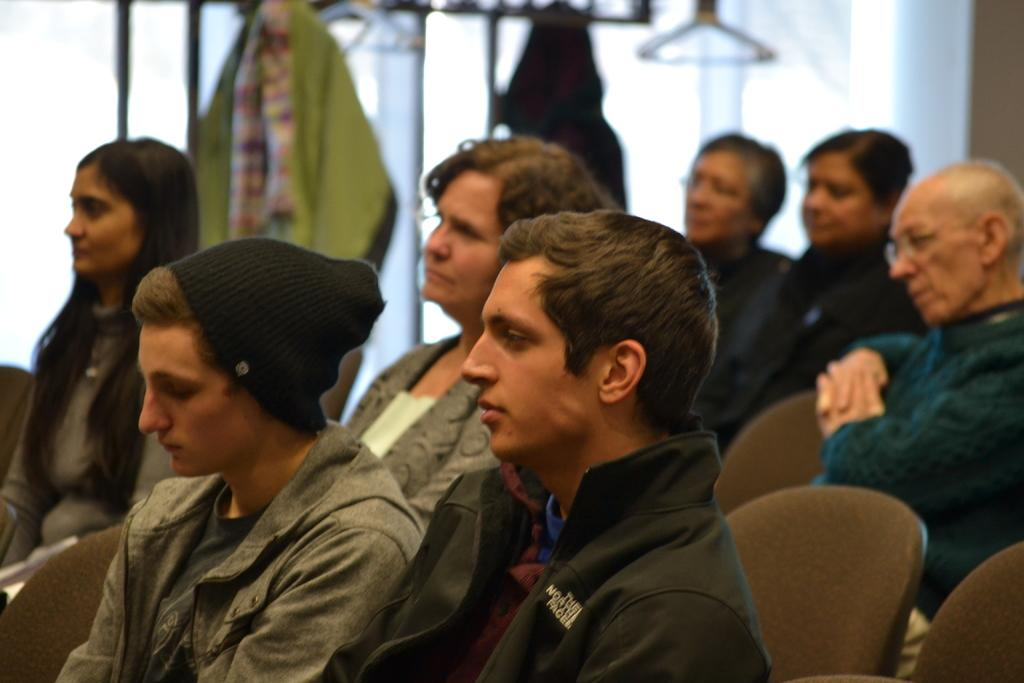What are the people in the image doing? The people in the image are sitting. What can be seen in the background of the image? There are clothes on hangers and a wall visible in the background of the image. What type of horn can be heard in the image? There is no horn present in the image, and therefore no sound can be heard. 